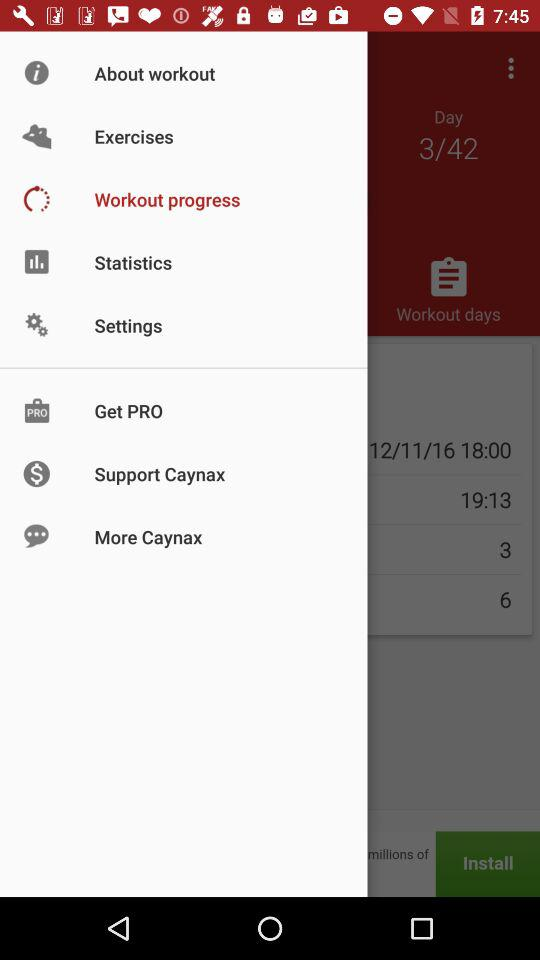Which are the selected exercises?
When the provided information is insufficient, respond with <no answer>. <no answer> 